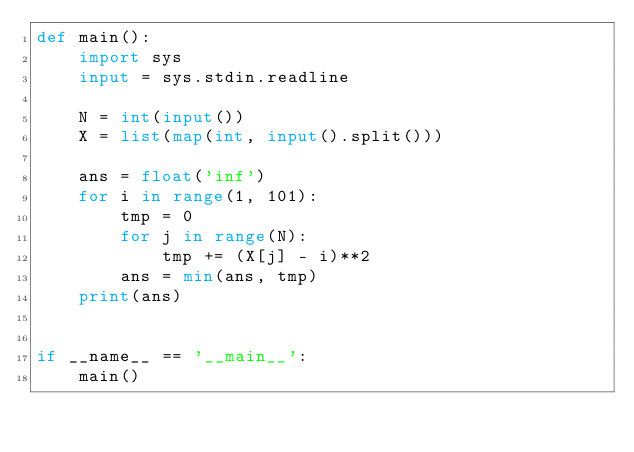Convert code to text. <code><loc_0><loc_0><loc_500><loc_500><_Python_>def main():
    import sys
    input = sys.stdin.readline

    N = int(input())
    X = list(map(int, input().split()))

    ans = float('inf')
    for i in range(1, 101):
        tmp = 0
        for j in range(N):
            tmp += (X[j] - i)**2
        ans = min(ans, tmp)
    print(ans)
    

if __name__ == '__main__':
    main()
</code> 